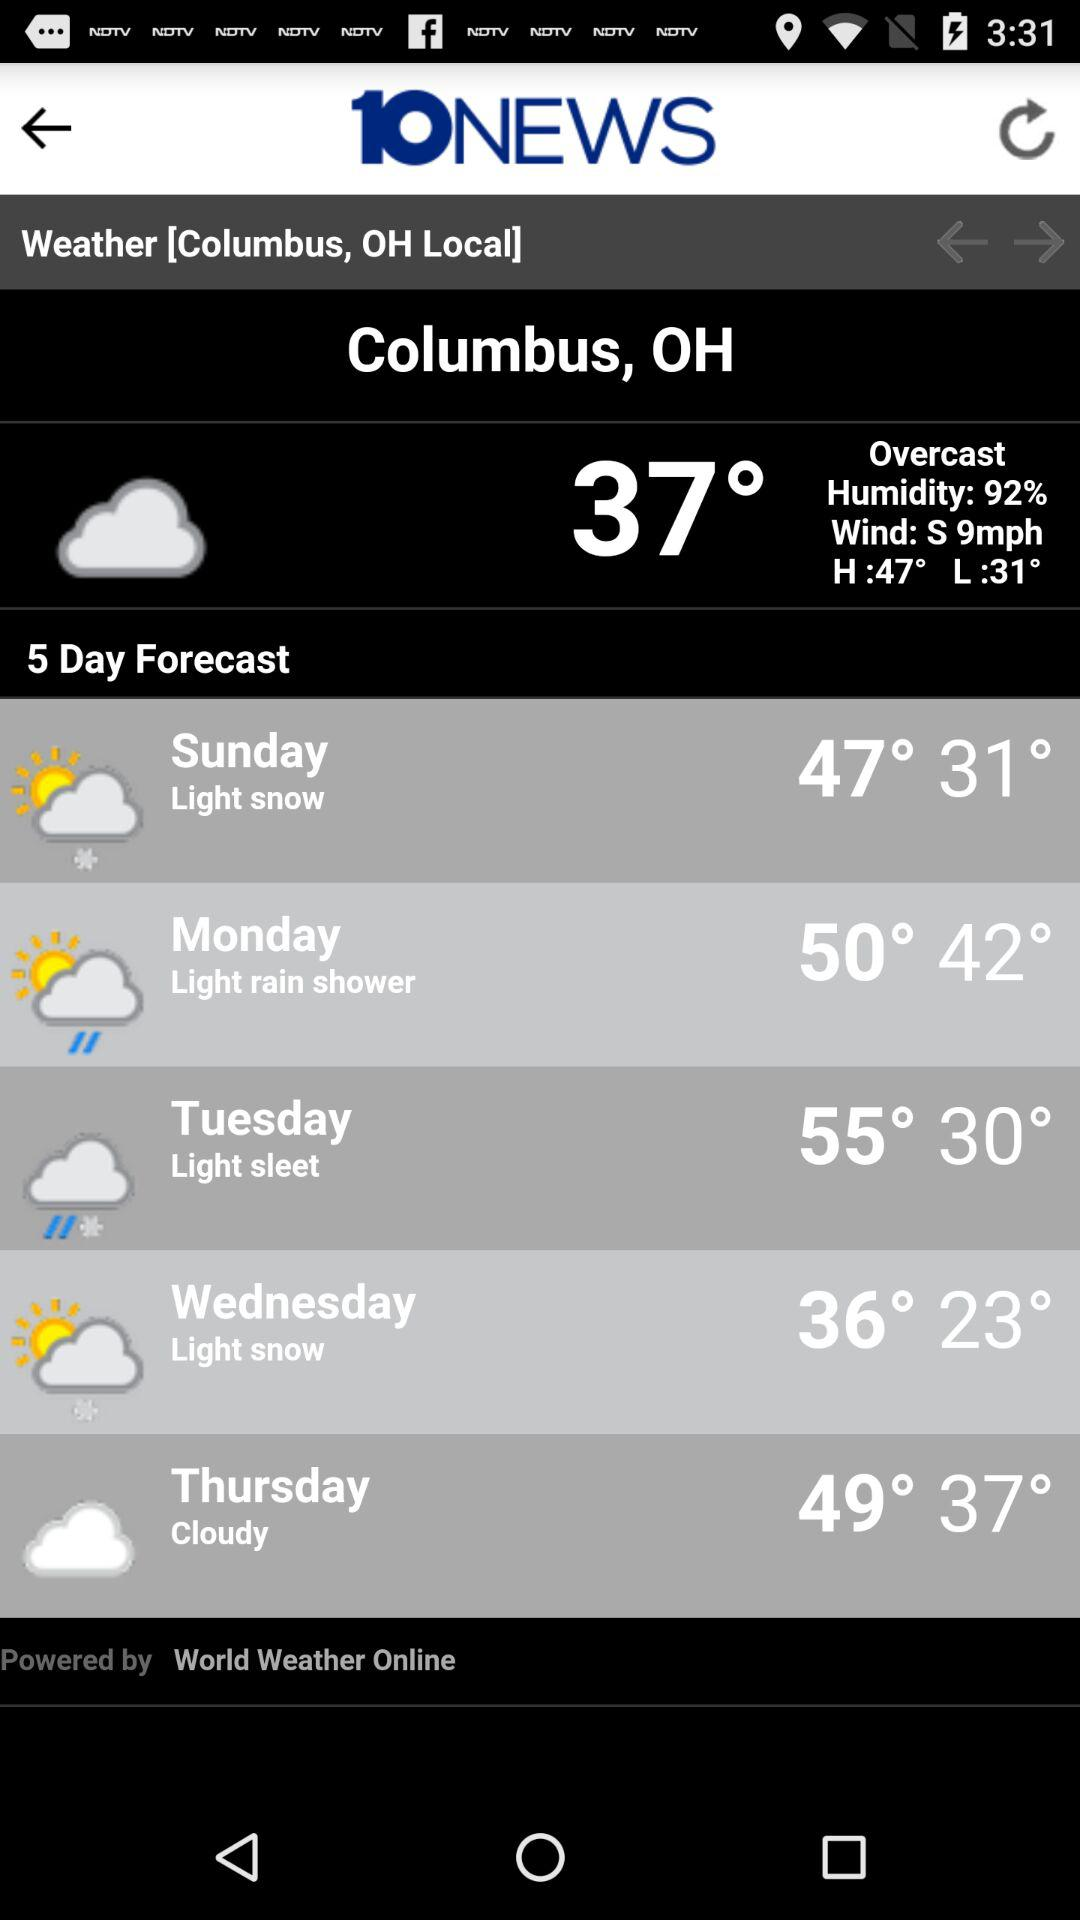What is the name of the application? The name of the application is "10NEWS". 